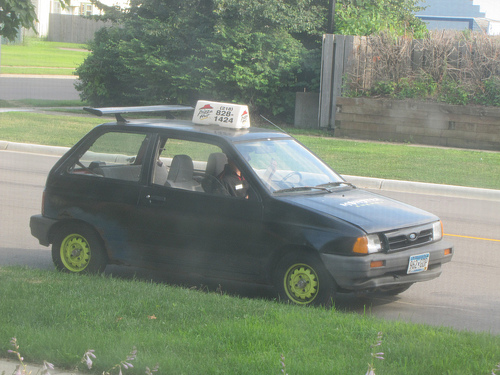<image>
Can you confirm if the car is under the wall? No. The car is not positioned under the wall. The vertical relationship between these objects is different. Is the car behind the grass? Yes. From this viewpoint, the car is positioned behind the grass, with the grass partially or fully occluding the car. Is the sign on the car? Yes. Looking at the image, I can see the sign is positioned on top of the car, with the car providing support. Is there a car on the grass? No. The car is not positioned on the grass. They may be near each other, but the car is not supported by or resting on top of the grass. 